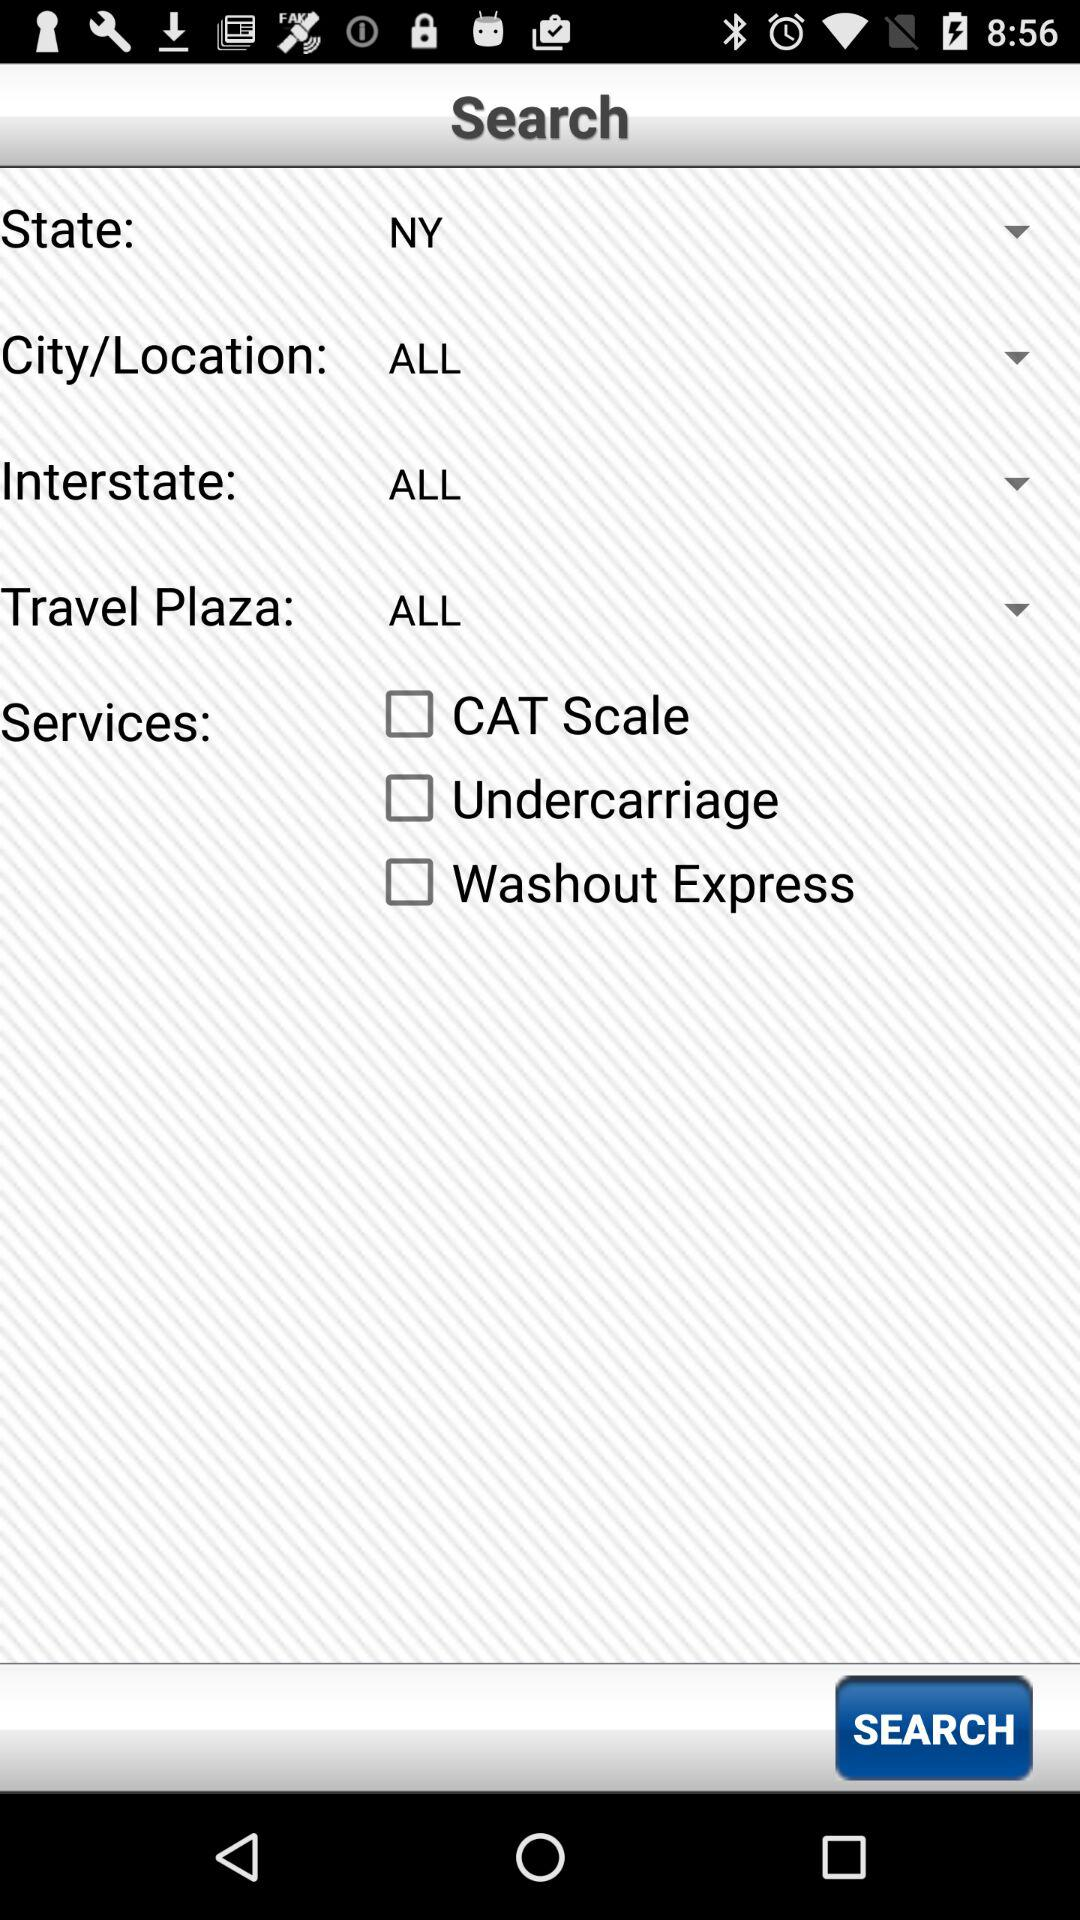How many services are available?
Answer the question using a single word or phrase. 3 